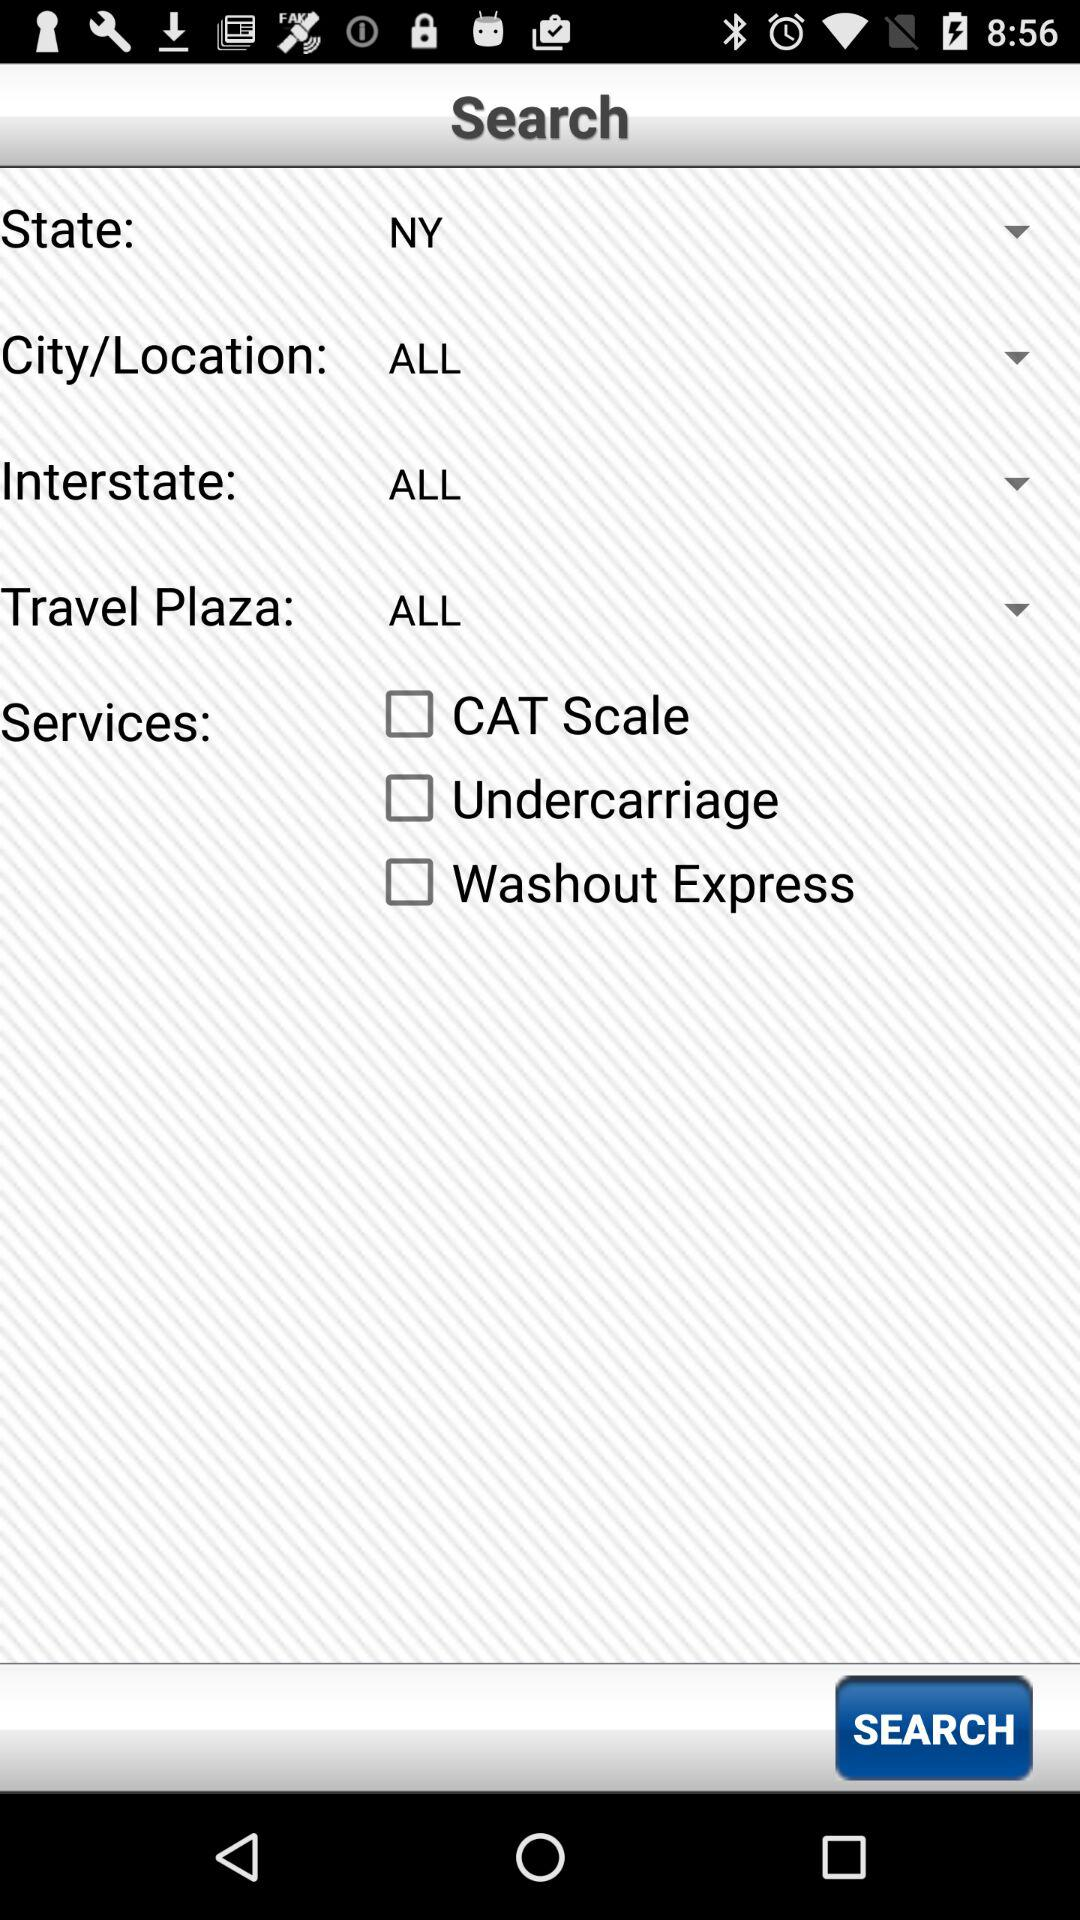How many services are available?
Answer the question using a single word or phrase. 3 